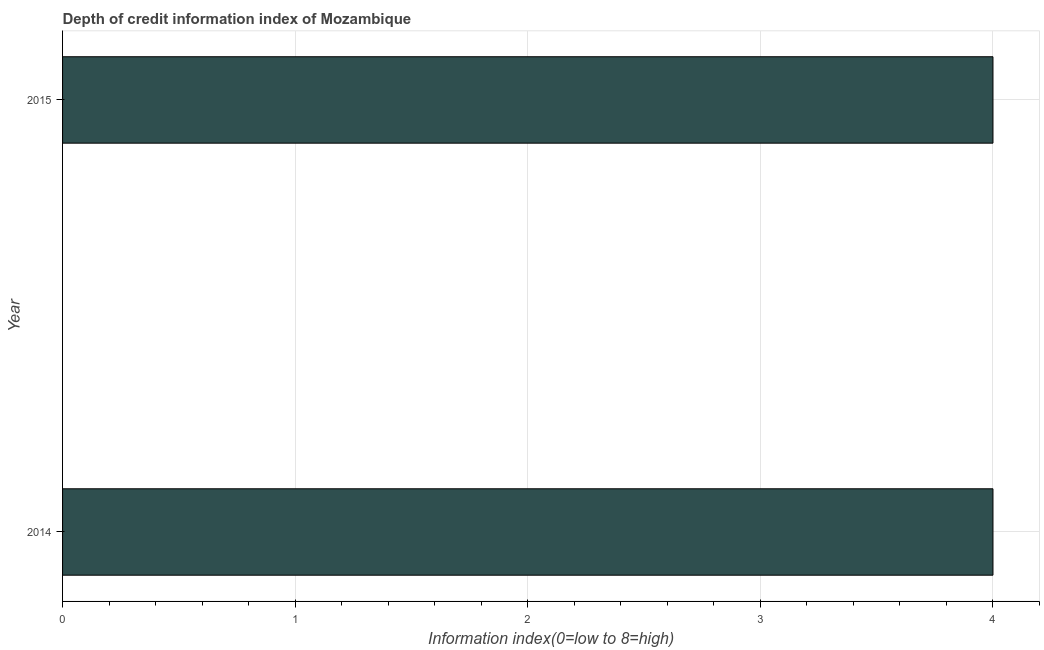Does the graph contain any zero values?
Your answer should be compact. No. What is the title of the graph?
Offer a very short reply. Depth of credit information index of Mozambique. What is the label or title of the X-axis?
Offer a terse response. Information index(0=low to 8=high). What is the label or title of the Y-axis?
Offer a very short reply. Year. Across all years, what is the minimum depth of credit information index?
Keep it short and to the point. 4. In which year was the depth of credit information index maximum?
Keep it short and to the point. 2014. In which year was the depth of credit information index minimum?
Make the answer very short. 2014. What is the sum of the depth of credit information index?
Keep it short and to the point. 8. What is the average depth of credit information index per year?
Give a very brief answer. 4. What is the median depth of credit information index?
Keep it short and to the point. 4. In how many years, is the depth of credit information index greater than 3.8 ?
Provide a succinct answer. 2. Are all the bars in the graph horizontal?
Offer a terse response. Yes. What is the difference between two consecutive major ticks on the X-axis?
Your answer should be very brief. 1. Are the values on the major ticks of X-axis written in scientific E-notation?
Keep it short and to the point. No. What is the Information index(0=low to 8=high) of 2014?
Your answer should be compact. 4. What is the difference between the Information index(0=low to 8=high) in 2014 and 2015?
Offer a very short reply. 0. 